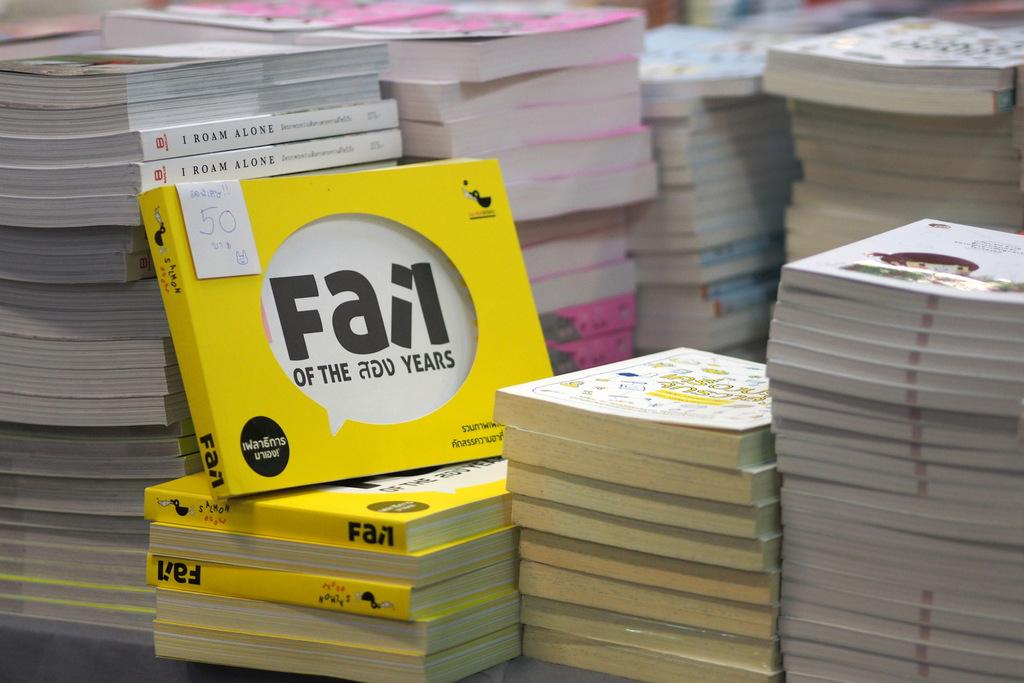<image>
Describe the image concisely. Yellow book that has the word "Fail" in the middle. 